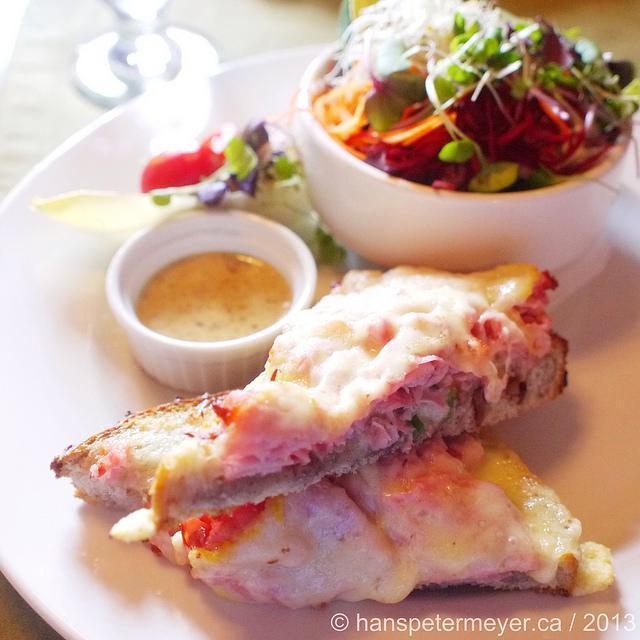How many bowls?
Give a very brief answer. 2. How many bowls can you see?
Give a very brief answer. 2. 